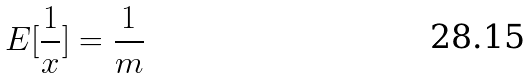<formula> <loc_0><loc_0><loc_500><loc_500>E [ \frac { 1 } { x } ] = \frac { 1 } { m }</formula> 